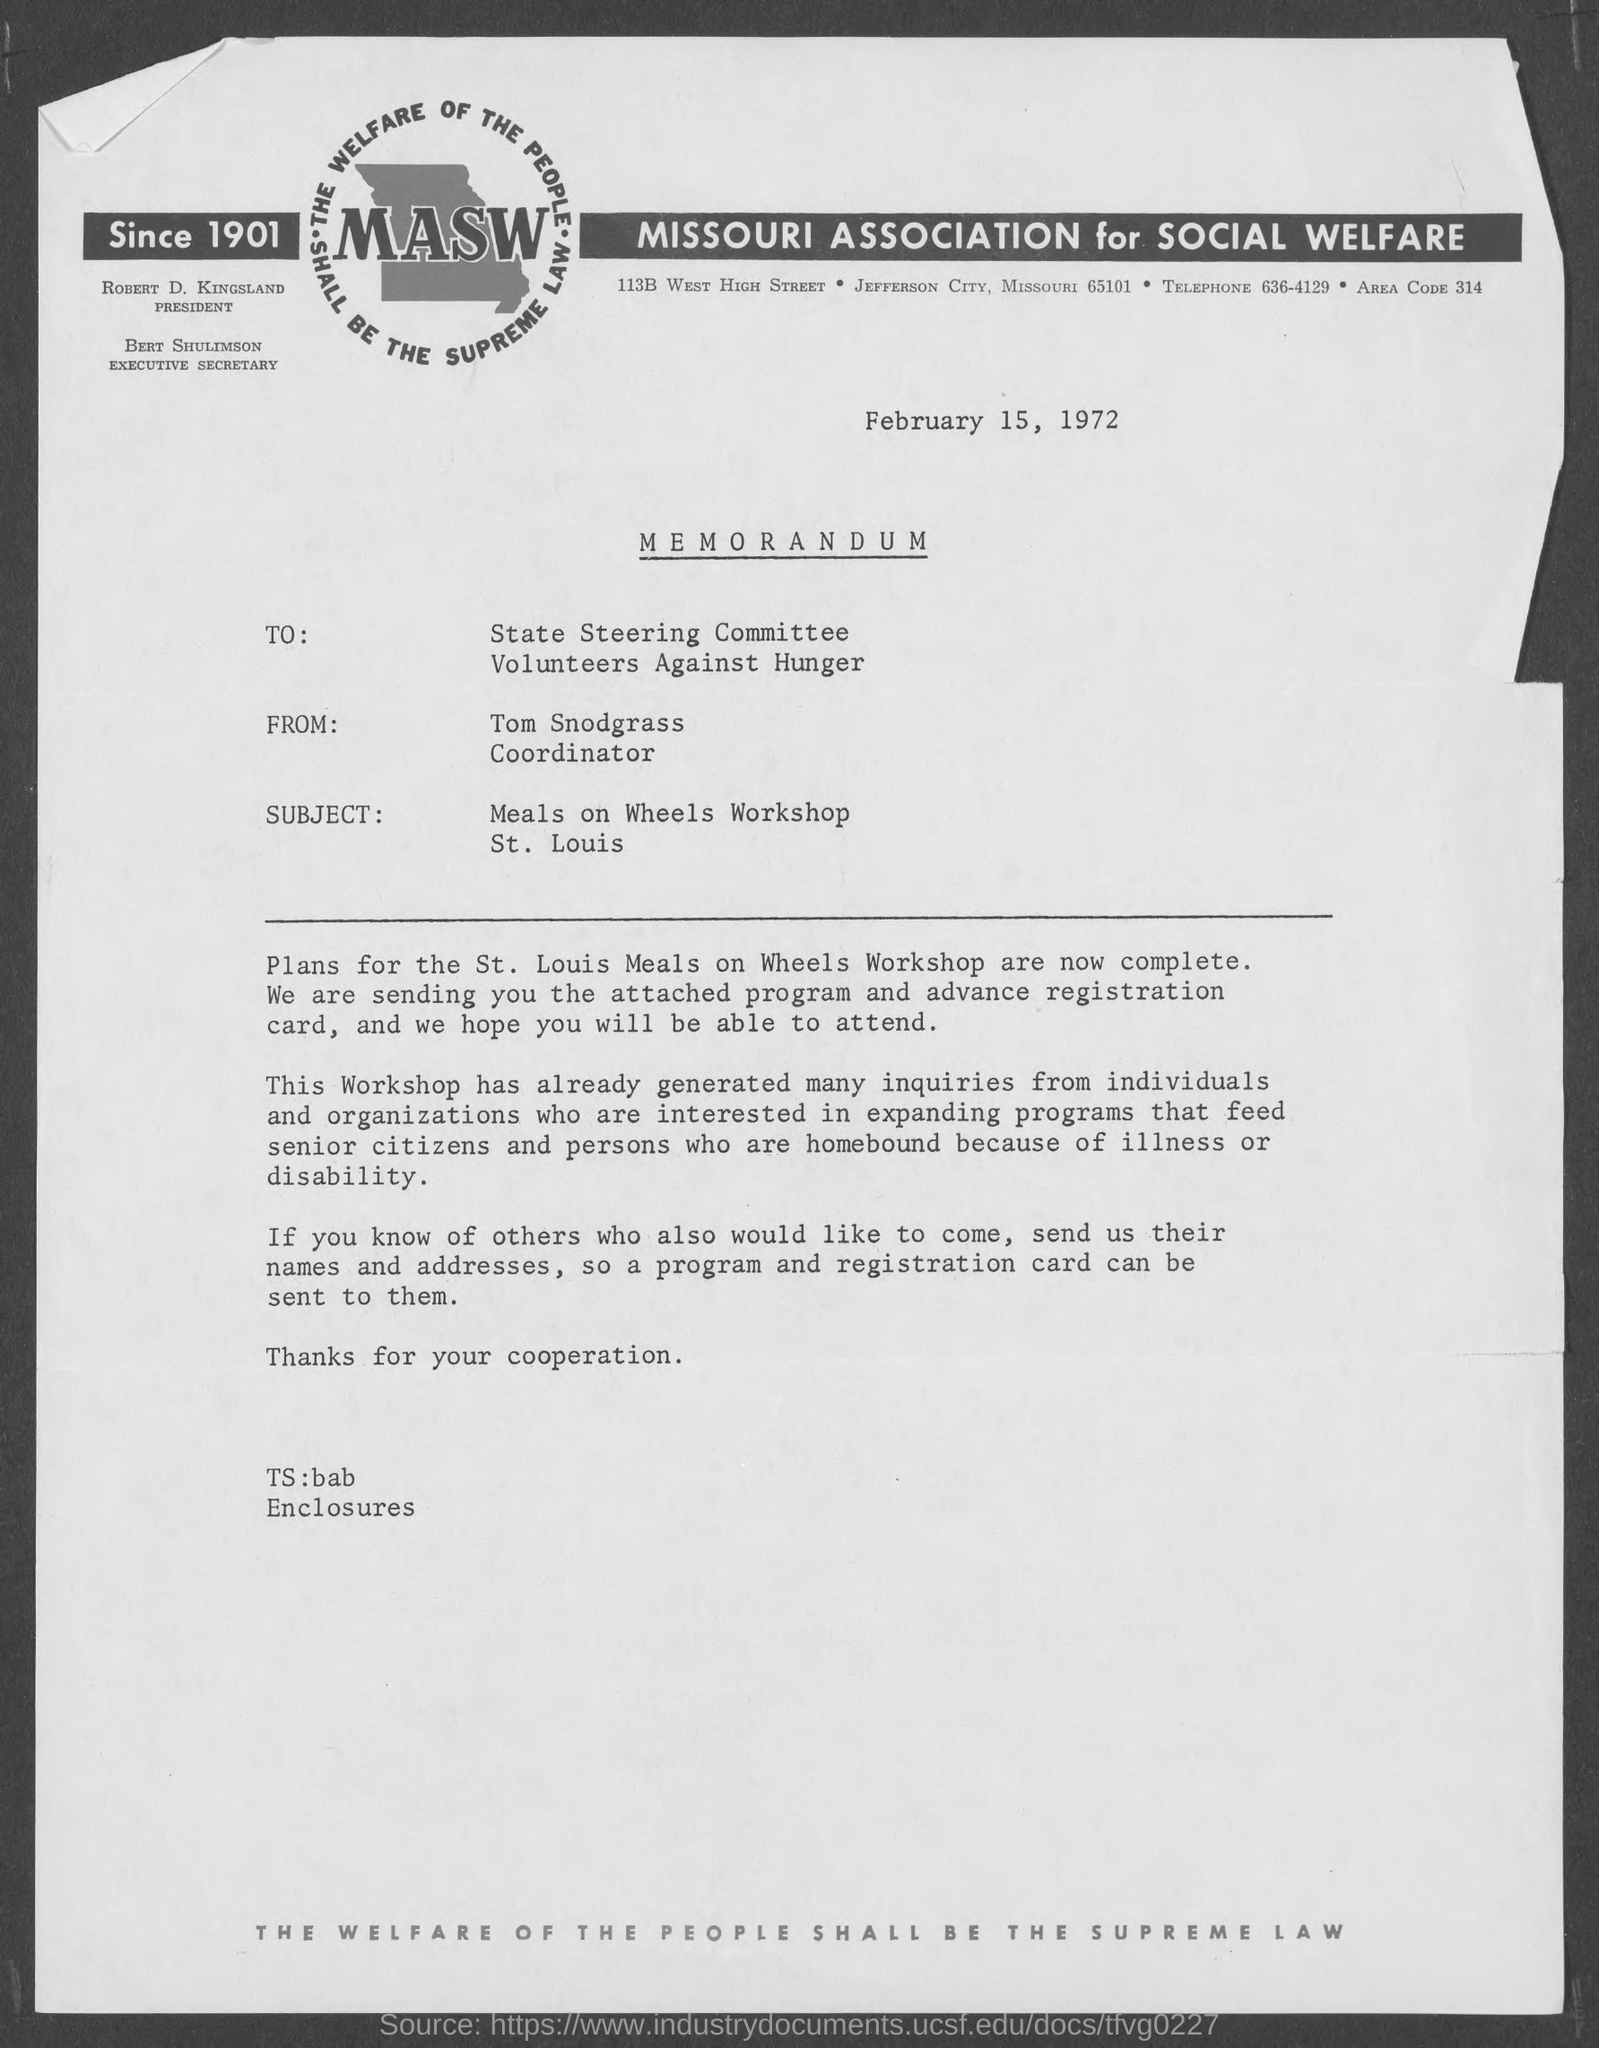Indicate a few pertinent items in this graphic. MASW, which stands for Missouri Association for Social Welfare, is a non-profit organization dedicated to promoting social welfare and improving the lives of individuals and communities in the state of Missouri. The date mentioned in the memorandum is February 15, 1972. The subject of this memorandum is the Meals on Wheels Workshop that took place in St. Louis. Tom Snodgrass's designation is Coordinator. The memorandum is from Tom Snodgrass. 